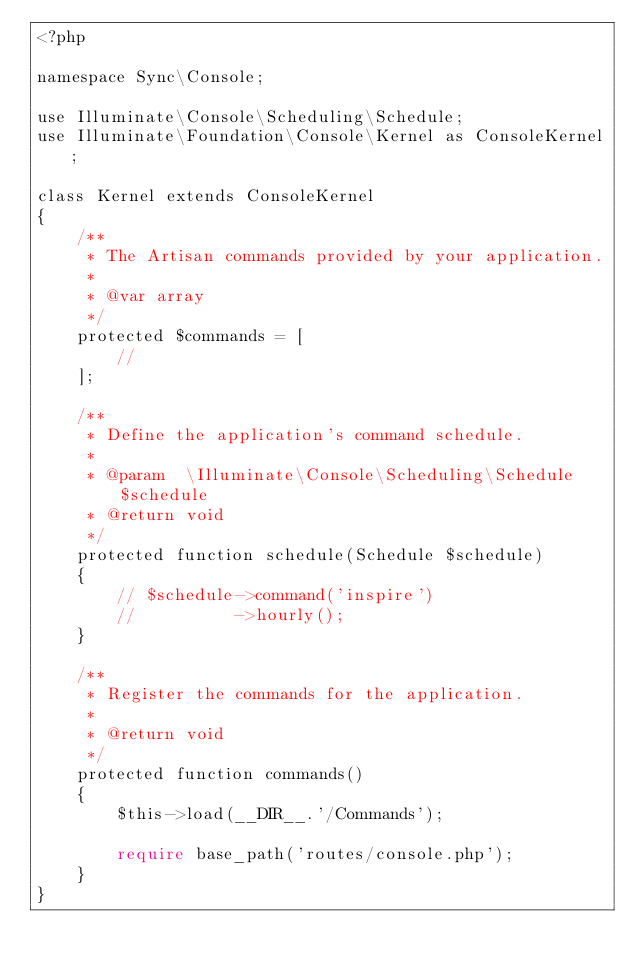Convert code to text. <code><loc_0><loc_0><loc_500><loc_500><_PHP_><?php

namespace Sync\Console;

use Illuminate\Console\Scheduling\Schedule;
use Illuminate\Foundation\Console\Kernel as ConsoleKernel;

class Kernel extends ConsoleKernel
{
    /**
     * The Artisan commands provided by your application.
     *
     * @var array
     */
    protected $commands = [
        //
    ];

    /**
     * Define the application's command schedule.
     *
     * @param  \Illuminate\Console\Scheduling\Schedule  $schedule
     * @return void
     */
    protected function schedule(Schedule $schedule)
    {
        // $schedule->command('inspire')
        //          ->hourly();
    }

    /**
     * Register the commands for the application.
     *
     * @return void
     */
    protected function commands()
    {
        $this->load(__DIR__.'/Commands');

        require base_path('routes/console.php');
    }
}
</code> 